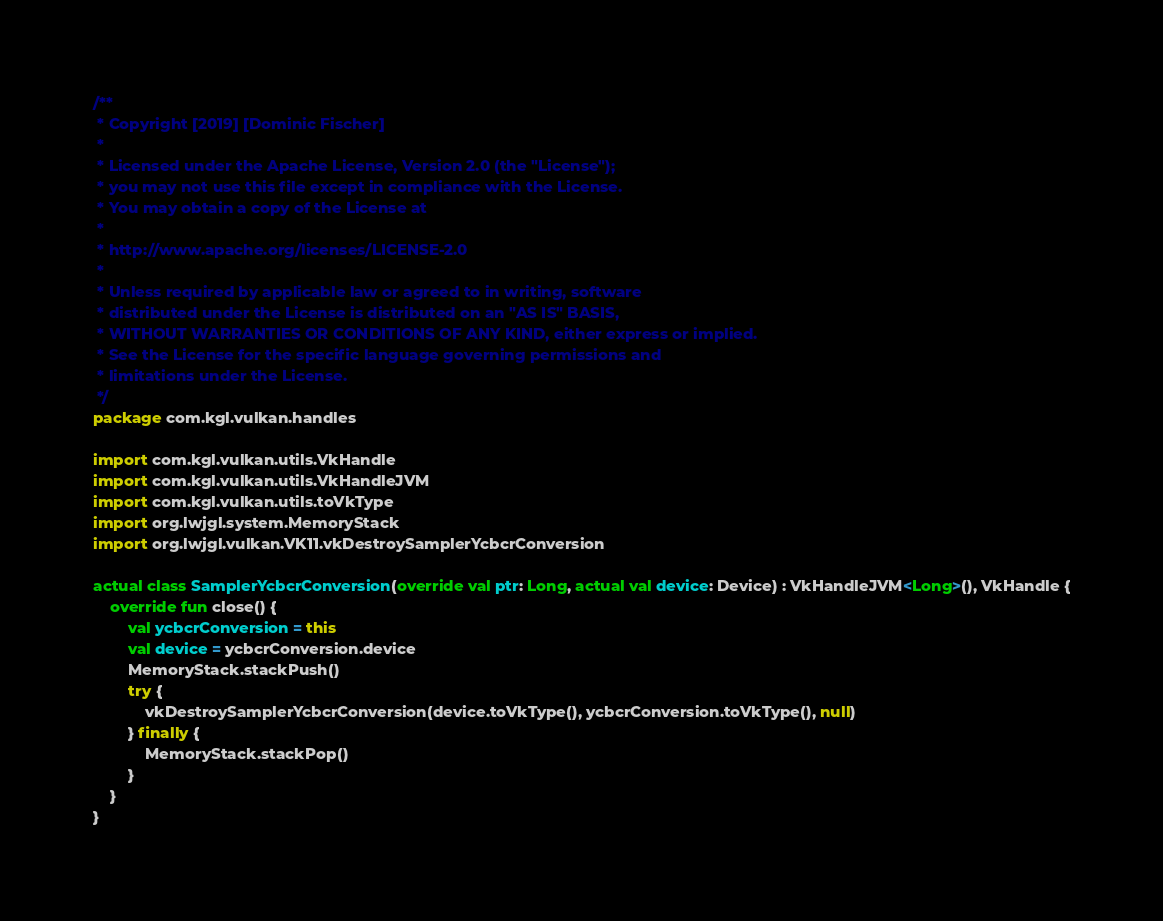Convert code to text. <code><loc_0><loc_0><loc_500><loc_500><_Kotlin_>/**
 * Copyright [2019] [Dominic Fischer]
 *
 * Licensed under the Apache License, Version 2.0 (the "License");
 * you may not use this file except in compliance with the License.
 * You may obtain a copy of the License at
 *
 * http://www.apache.org/licenses/LICENSE-2.0
 *
 * Unless required by applicable law or agreed to in writing, software
 * distributed under the License is distributed on an "AS IS" BASIS,
 * WITHOUT WARRANTIES OR CONDITIONS OF ANY KIND, either express or implied.
 * See the License for the specific language governing permissions and
 * limitations under the License.
 */
package com.kgl.vulkan.handles

import com.kgl.vulkan.utils.VkHandle
import com.kgl.vulkan.utils.VkHandleJVM
import com.kgl.vulkan.utils.toVkType
import org.lwjgl.system.MemoryStack
import org.lwjgl.vulkan.VK11.vkDestroySamplerYcbcrConversion

actual class SamplerYcbcrConversion(override val ptr: Long, actual val device: Device) : VkHandleJVM<Long>(), VkHandle {
	override fun close() {
		val ycbcrConversion = this
		val device = ycbcrConversion.device
		MemoryStack.stackPush()
		try {
			vkDestroySamplerYcbcrConversion(device.toVkType(), ycbcrConversion.toVkType(), null)
		} finally {
			MemoryStack.stackPop()
		}
	}
}

</code> 